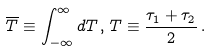Convert formula to latex. <formula><loc_0><loc_0><loc_500><loc_500>\overline { T } \equiv \int _ { - \infty } ^ { \infty } d T \, , \, T \equiv \frac { \tau _ { 1 } + \tau _ { 2 } } 2 \, .</formula> 